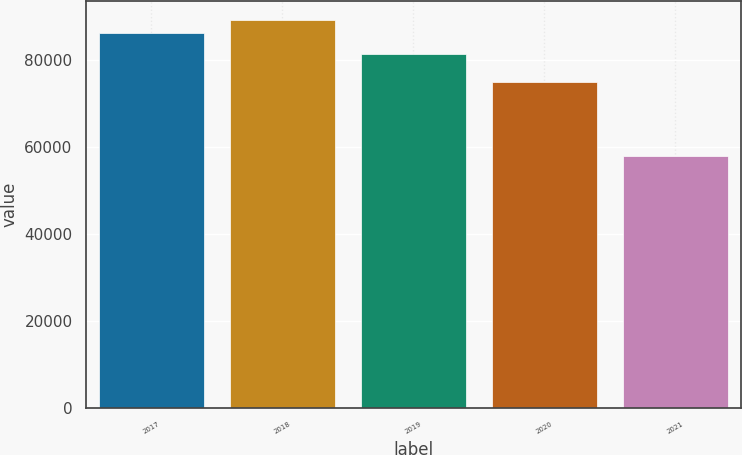Convert chart to OTSL. <chart><loc_0><loc_0><loc_500><loc_500><bar_chart><fcel>2017<fcel>2018<fcel>2019<fcel>2020<fcel>2021<nl><fcel>86357<fcel>89235.2<fcel>81434<fcel>74955<fcel>57862<nl></chart> 